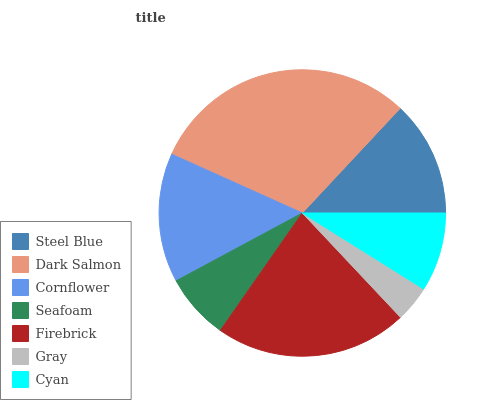Is Gray the minimum?
Answer yes or no. Yes. Is Dark Salmon the maximum?
Answer yes or no. Yes. Is Cornflower the minimum?
Answer yes or no. No. Is Cornflower the maximum?
Answer yes or no. No. Is Dark Salmon greater than Cornflower?
Answer yes or no. Yes. Is Cornflower less than Dark Salmon?
Answer yes or no. Yes. Is Cornflower greater than Dark Salmon?
Answer yes or no. No. Is Dark Salmon less than Cornflower?
Answer yes or no. No. Is Steel Blue the high median?
Answer yes or no. Yes. Is Steel Blue the low median?
Answer yes or no. Yes. Is Seafoam the high median?
Answer yes or no. No. Is Gray the low median?
Answer yes or no. No. 